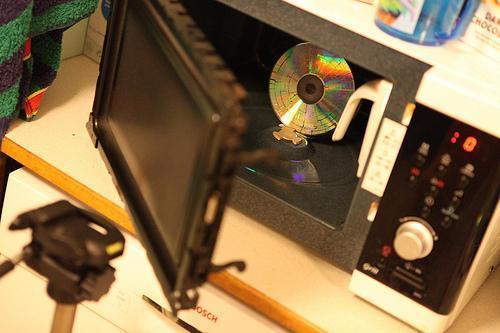How many camera stands are in the photo?
Give a very brief answer. 1. How many cds are in the microwave?
Give a very brief answer. 1. 